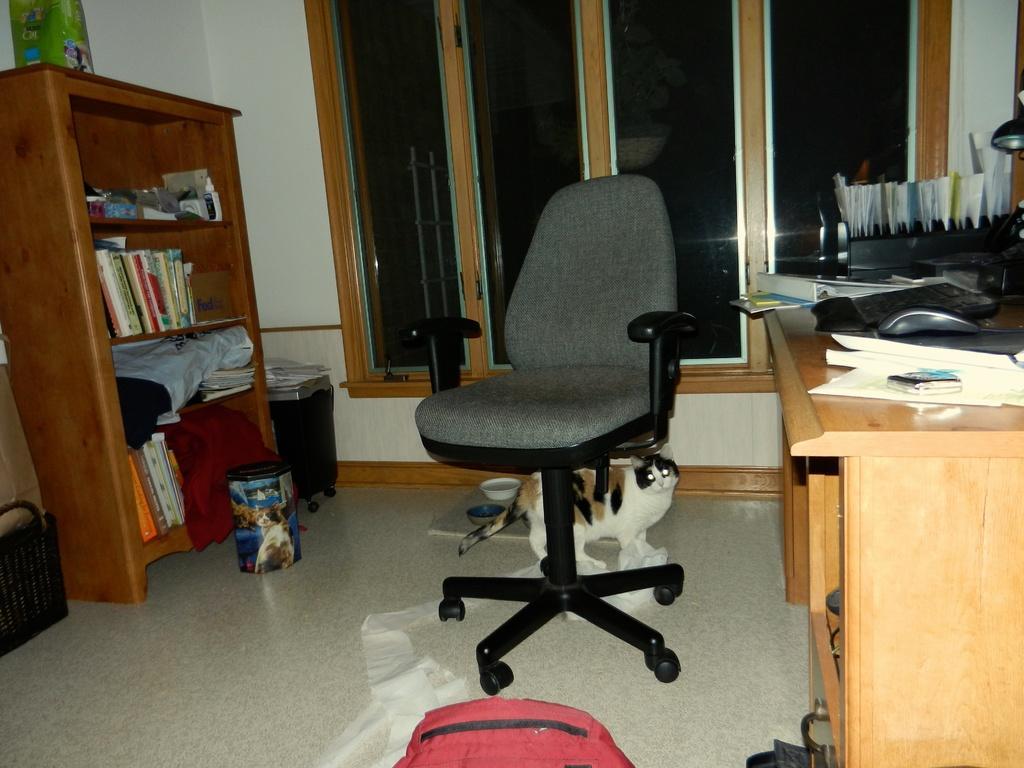How would you summarize this image in a sentence or two? In this image ii can see a chair there is a cat under the chair at the right there are few books, papers on the table at right there are few other books in a rack, at the back ground i can see a window and a wall. 